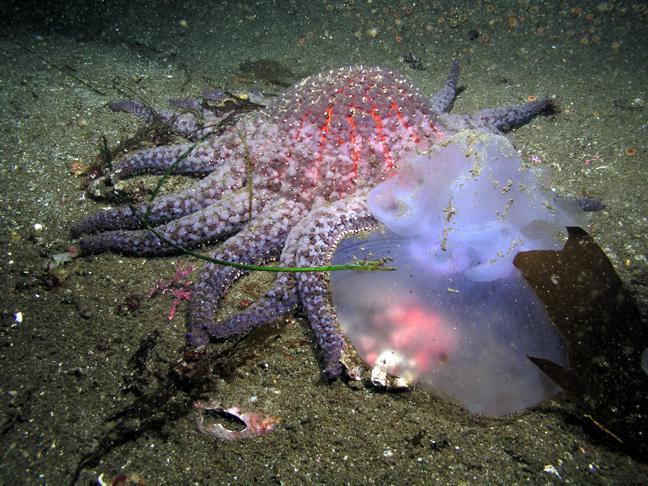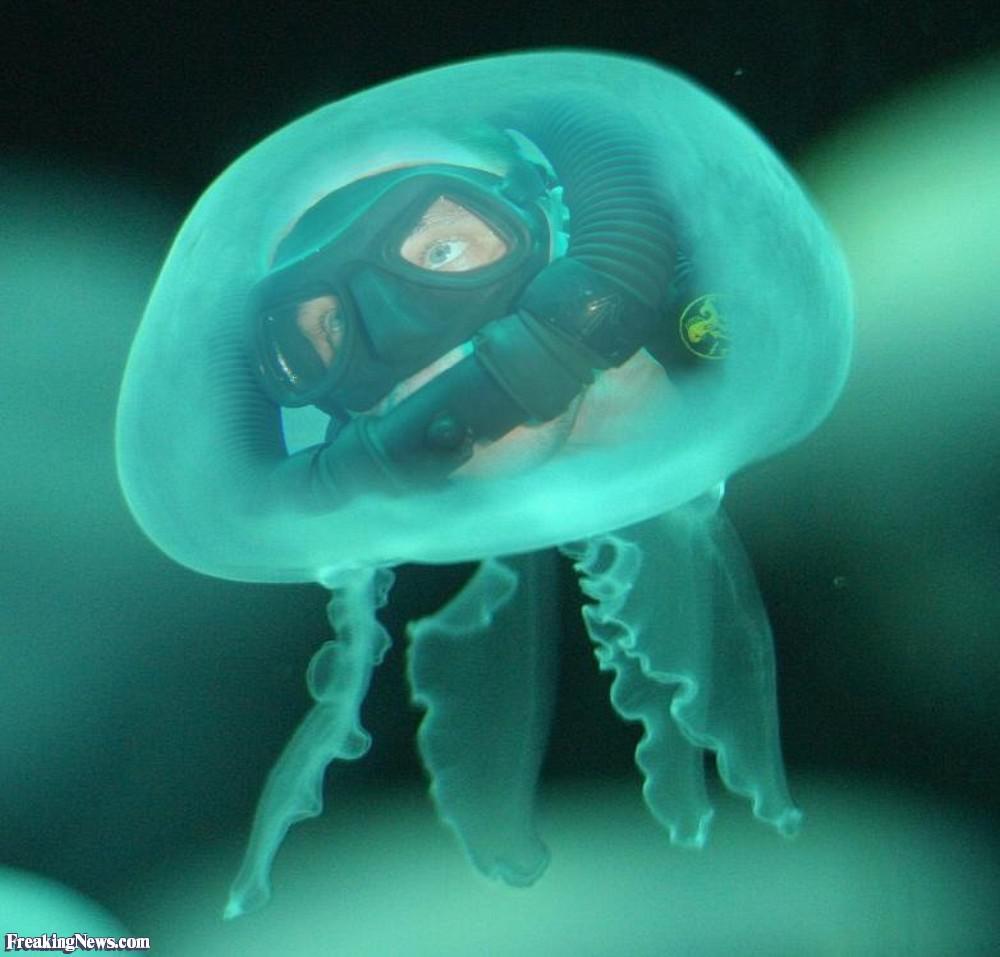The first image is the image on the left, the second image is the image on the right. Analyze the images presented: Is the assertion "sunlight can be seen in the surface ripples of the image on the left" valid? Answer yes or no. No. The first image is the image on the left, the second image is the image on the right. Given the left and right images, does the statement "Left image shows one animal to the left of a violet-tinted jellyfish." hold true? Answer yes or no. Yes. 